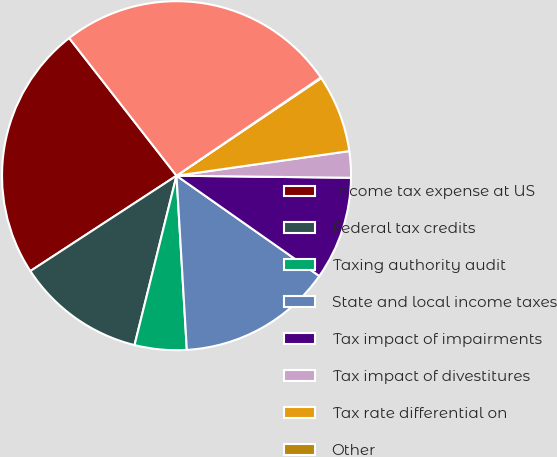Convert chart. <chart><loc_0><loc_0><loc_500><loc_500><pie_chart><fcel>Income tax expense at US<fcel>Federal tax credits<fcel>Taxing authority audit<fcel>State and local income taxes<fcel>Tax impact of impairments<fcel>Tax impact of divestitures<fcel>Tax rate differential on<fcel>Other<fcel>Provision for income taxes<nl><fcel>23.66%<fcel>11.93%<fcel>4.81%<fcel>14.31%<fcel>9.56%<fcel>2.44%<fcel>7.19%<fcel>0.07%<fcel>26.03%<nl></chart> 